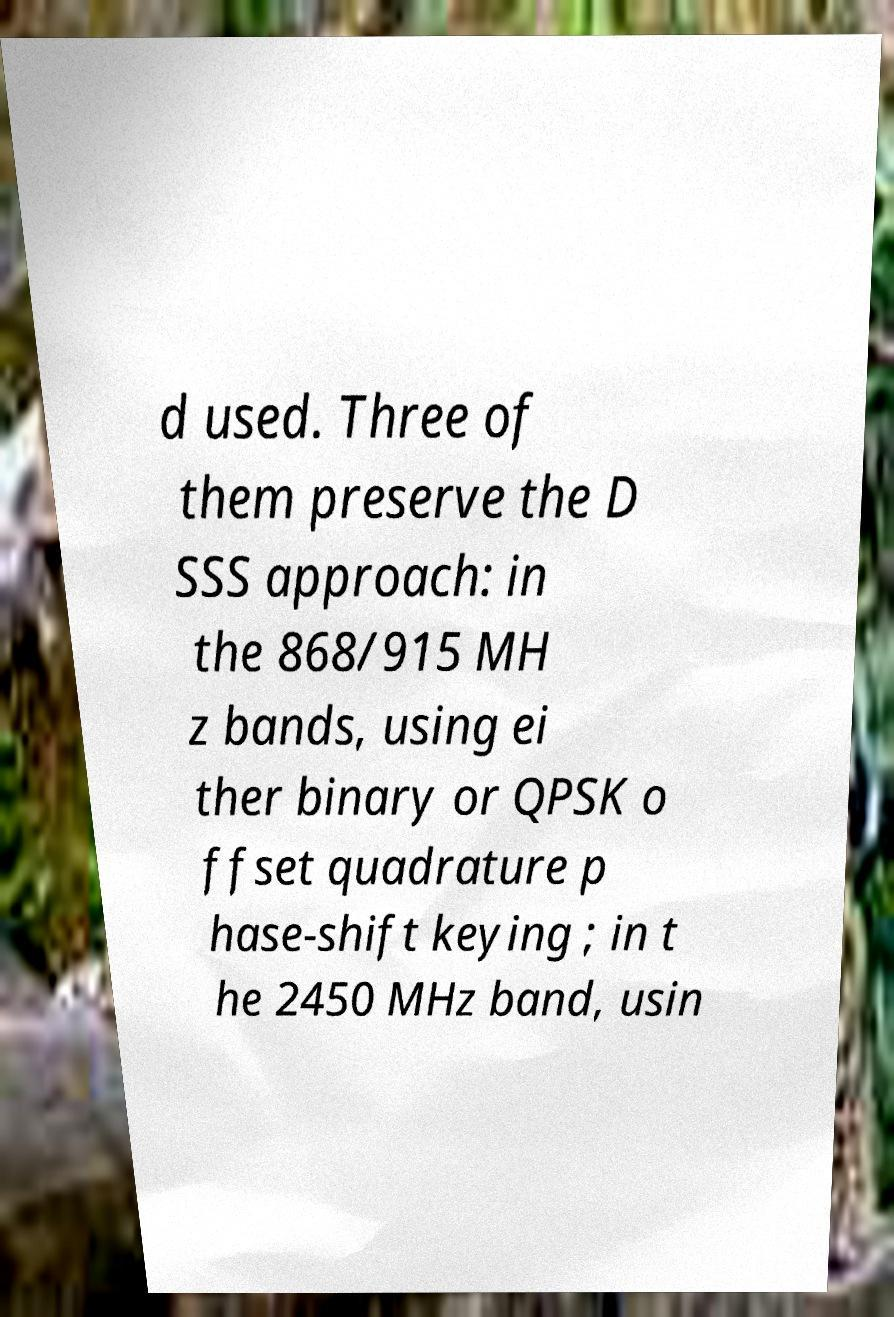Can you read and provide the text displayed in the image?This photo seems to have some interesting text. Can you extract and type it out for me? d used. Three of them preserve the D SSS approach: in the 868/915 MH z bands, using ei ther binary or QPSK o ffset quadrature p hase-shift keying ; in t he 2450 MHz band, usin 